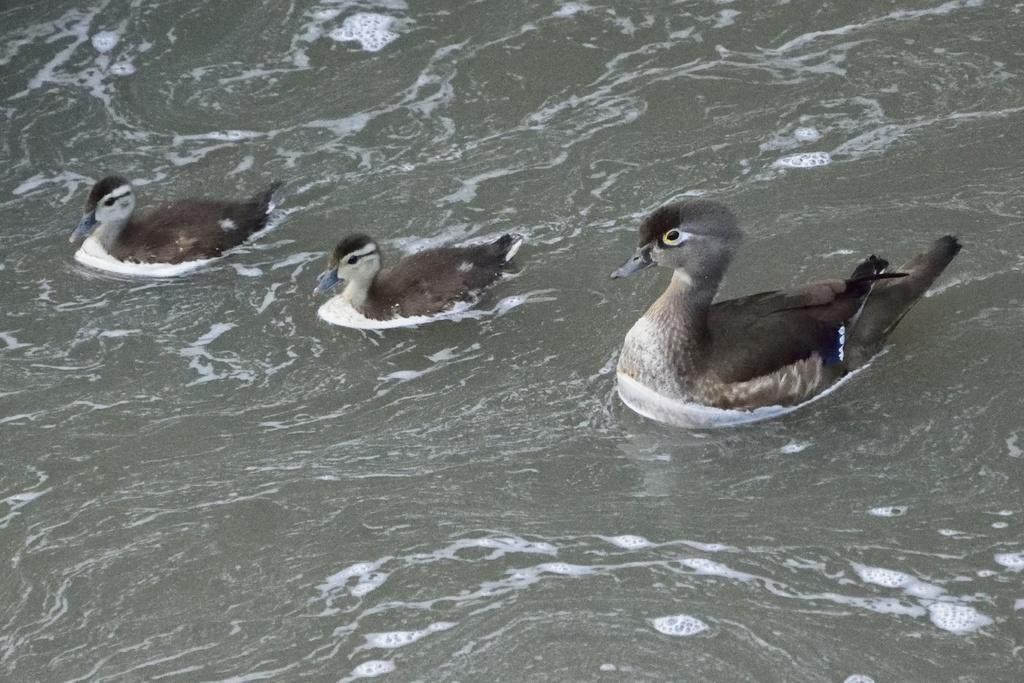Can you describe this image briefly? In this image, I can see three ducks in the water. This looks like a foam floating on the water. 